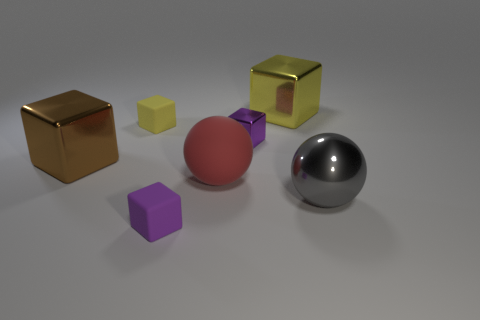There is a tiny metal object; does it have the same color as the small matte cube that is in front of the purple shiny block?
Offer a very short reply. Yes. What is the color of the tiny object on the right side of the big matte ball?
Your answer should be compact. Purple. What shape is the shiny object in front of the sphere that is left of the large yellow metal object?
Your answer should be compact. Sphere. Is the material of the red thing the same as the tiny purple cube that is to the left of the matte ball?
Offer a terse response. Yes. The tiny thing that is the same color as the small metal cube is what shape?
Your response must be concise. Cube. How many other cubes have the same size as the yellow metallic cube?
Provide a succinct answer. 1. Is the number of big red things that are behind the big red object less than the number of big things?
Make the answer very short. Yes. How many gray balls are left of the purple shiny block?
Provide a short and direct response. 0. How big is the yellow cube right of the tiny purple block behind the purple object that is in front of the brown shiny thing?
Offer a very short reply. Large. There is a small metallic thing; is its shape the same as the large shiny thing in front of the large brown shiny thing?
Make the answer very short. No. 